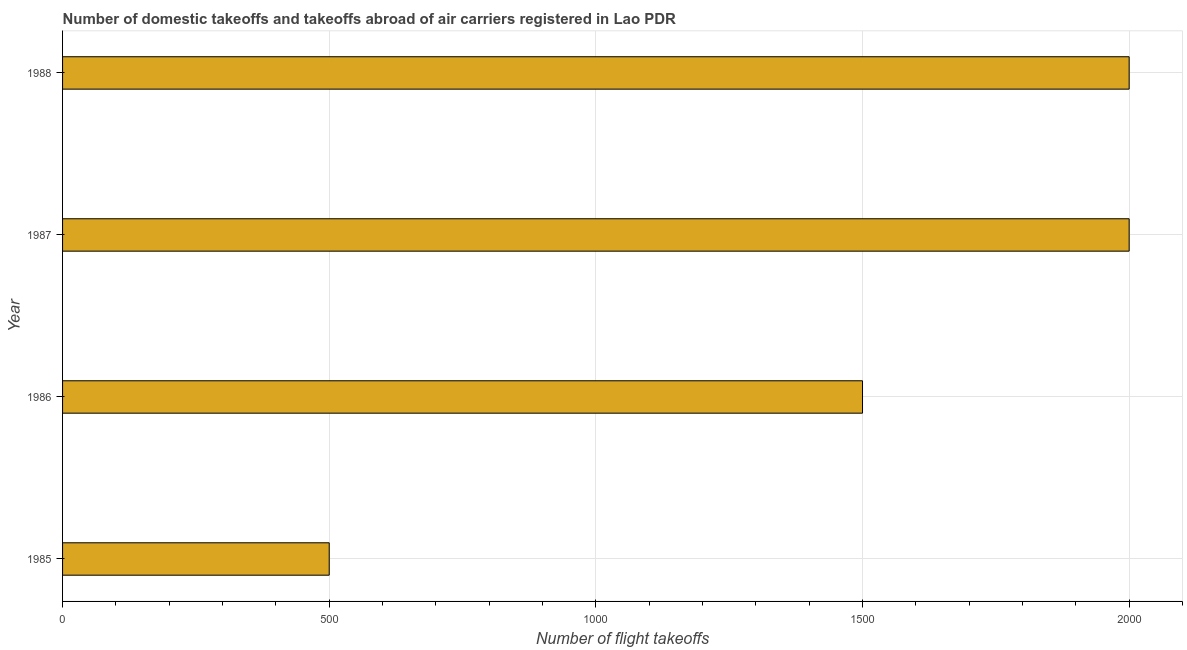What is the title of the graph?
Give a very brief answer. Number of domestic takeoffs and takeoffs abroad of air carriers registered in Lao PDR. What is the label or title of the X-axis?
Keep it short and to the point. Number of flight takeoffs. What is the label or title of the Y-axis?
Your answer should be very brief. Year. What is the number of flight takeoffs in 1987?
Provide a short and direct response. 2000. Across all years, what is the minimum number of flight takeoffs?
Provide a short and direct response. 500. In which year was the number of flight takeoffs maximum?
Your response must be concise. 1987. In which year was the number of flight takeoffs minimum?
Offer a terse response. 1985. What is the sum of the number of flight takeoffs?
Keep it short and to the point. 6000. What is the difference between the number of flight takeoffs in 1987 and 1988?
Your response must be concise. 0. What is the average number of flight takeoffs per year?
Give a very brief answer. 1500. What is the median number of flight takeoffs?
Give a very brief answer. 1750. Do a majority of the years between 1987 and 1988 (inclusive) have number of flight takeoffs greater than 1700 ?
Give a very brief answer. Yes. What is the ratio of the number of flight takeoffs in 1985 to that in 1986?
Offer a very short reply. 0.33. Is the number of flight takeoffs in 1985 less than that in 1986?
Provide a short and direct response. Yes. Is the difference between the number of flight takeoffs in 1985 and 1987 greater than the difference between any two years?
Keep it short and to the point. Yes. Is the sum of the number of flight takeoffs in 1987 and 1988 greater than the maximum number of flight takeoffs across all years?
Offer a terse response. Yes. What is the difference between the highest and the lowest number of flight takeoffs?
Your answer should be compact. 1500. Are all the bars in the graph horizontal?
Your answer should be very brief. Yes. What is the Number of flight takeoffs of 1986?
Ensure brevity in your answer.  1500. What is the Number of flight takeoffs of 1987?
Your response must be concise. 2000. What is the Number of flight takeoffs in 1988?
Offer a very short reply. 2000. What is the difference between the Number of flight takeoffs in 1985 and 1986?
Ensure brevity in your answer.  -1000. What is the difference between the Number of flight takeoffs in 1985 and 1987?
Provide a short and direct response. -1500. What is the difference between the Number of flight takeoffs in 1985 and 1988?
Your answer should be very brief. -1500. What is the difference between the Number of flight takeoffs in 1986 and 1987?
Offer a very short reply. -500. What is the difference between the Number of flight takeoffs in 1986 and 1988?
Give a very brief answer. -500. What is the difference between the Number of flight takeoffs in 1987 and 1988?
Make the answer very short. 0. What is the ratio of the Number of flight takeoffs in 1985 to that in 1986?
Provide a short and direct response. 0.33. What is the ratio of the Number of flight takeoffs in 1985 to that in 1987?
Your answer should be compact. 0.25. What is the ratio of the Number of flight takeoffs in 1987 to that in 1988?
Make the answer very short. 1. 